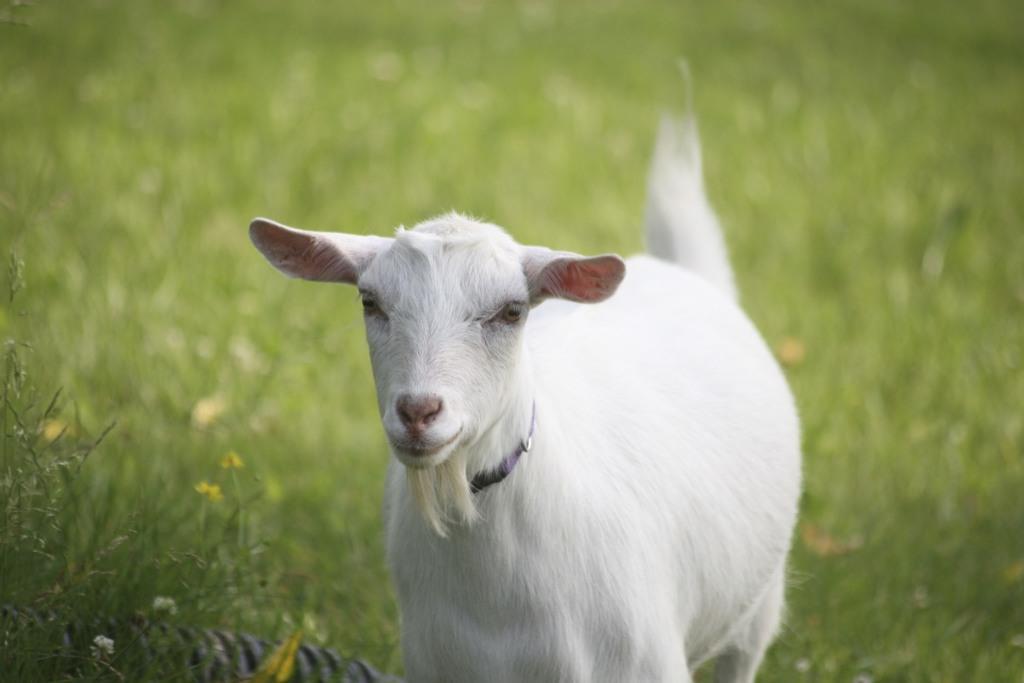Can you describe this image briefly? In the center of the image, we can see a lamb and in the background, there is ground covered with grass. 